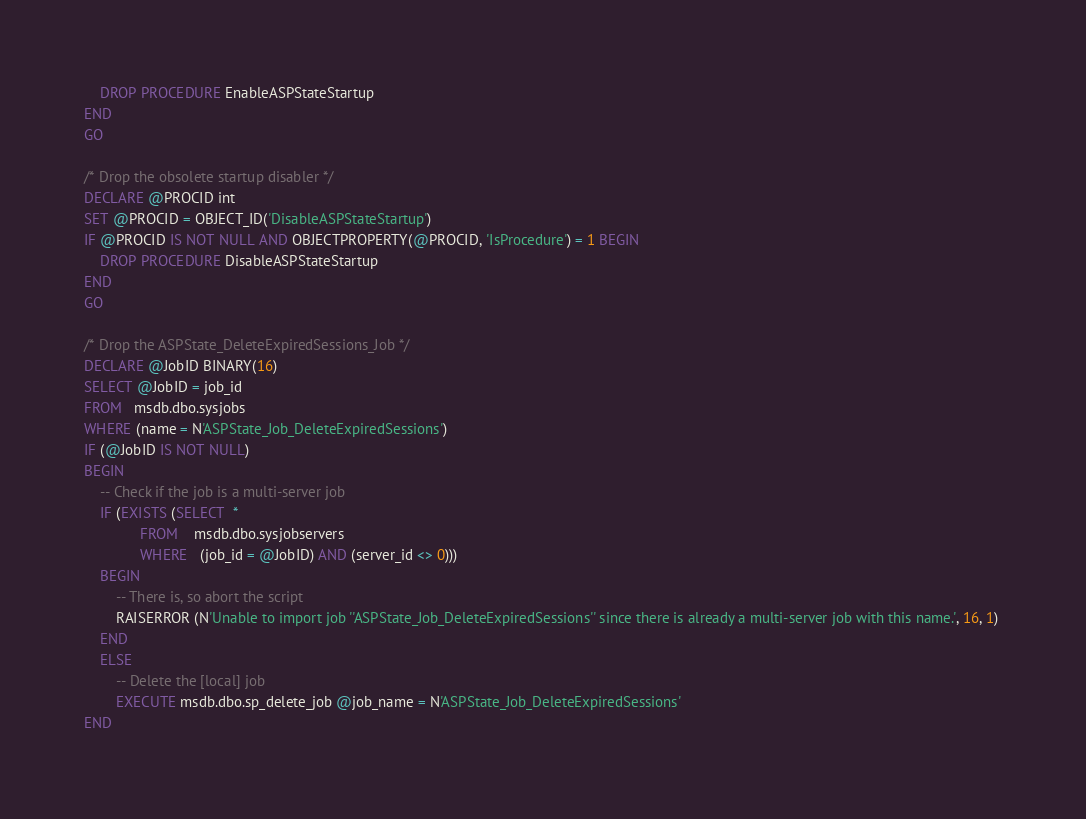<code> <loc_0><loc_0><loc_500><loc_500><_SQL_>    DROP PROCEDURE EnableASPStateStartup
END
GO

/* Drop the obsolete startup disabler */
DECLARE @PROCID int
SET @PROCID = OBJECT_ID('DisableASPStateStartup') 
IF @PROCID IS NOT NULL AND OBJECTPROPERTY(@PROCID, 'IsProcedure') = 1 BEGIN
    DROP PROCEDURE DisableASPStateStartup
END
GO

/* Drop the ASPState_DeleteExpiredSessions_Job */
DECLARE @JobID BINARY(16)  
SELECT @JobID = job_id     
FROM   msdb.dbo.sysjobs    
WHERE (name = N'ASPState_Job_DeleteExpiredSessions')       
IF (@JobID IS NOT NULL)    
BEGIN  
    -- Check if the job is a multi-server job  
    IF (EXISTS (SELECT  * 
              FROM    msdb.dbo.sysjobservers 
              WHERE   (job_id = @JobID) AND (server_id <> 0))) 
    BEGIN 
        -- There is, so abort the script 
        RAISERROR (N'Unable to import job ''ASPState_Job_DeleteExpiredSessions'' since there is already a multi-server job with this name.', 16, 1) 
    END 
    ELSE 
        -- Delete the [local] job 
        EXECUTE msdb.dbo.sp_delete_job @job_name = N'ASPState_Job_DeleteExpiredSessions' 
END

</code> 